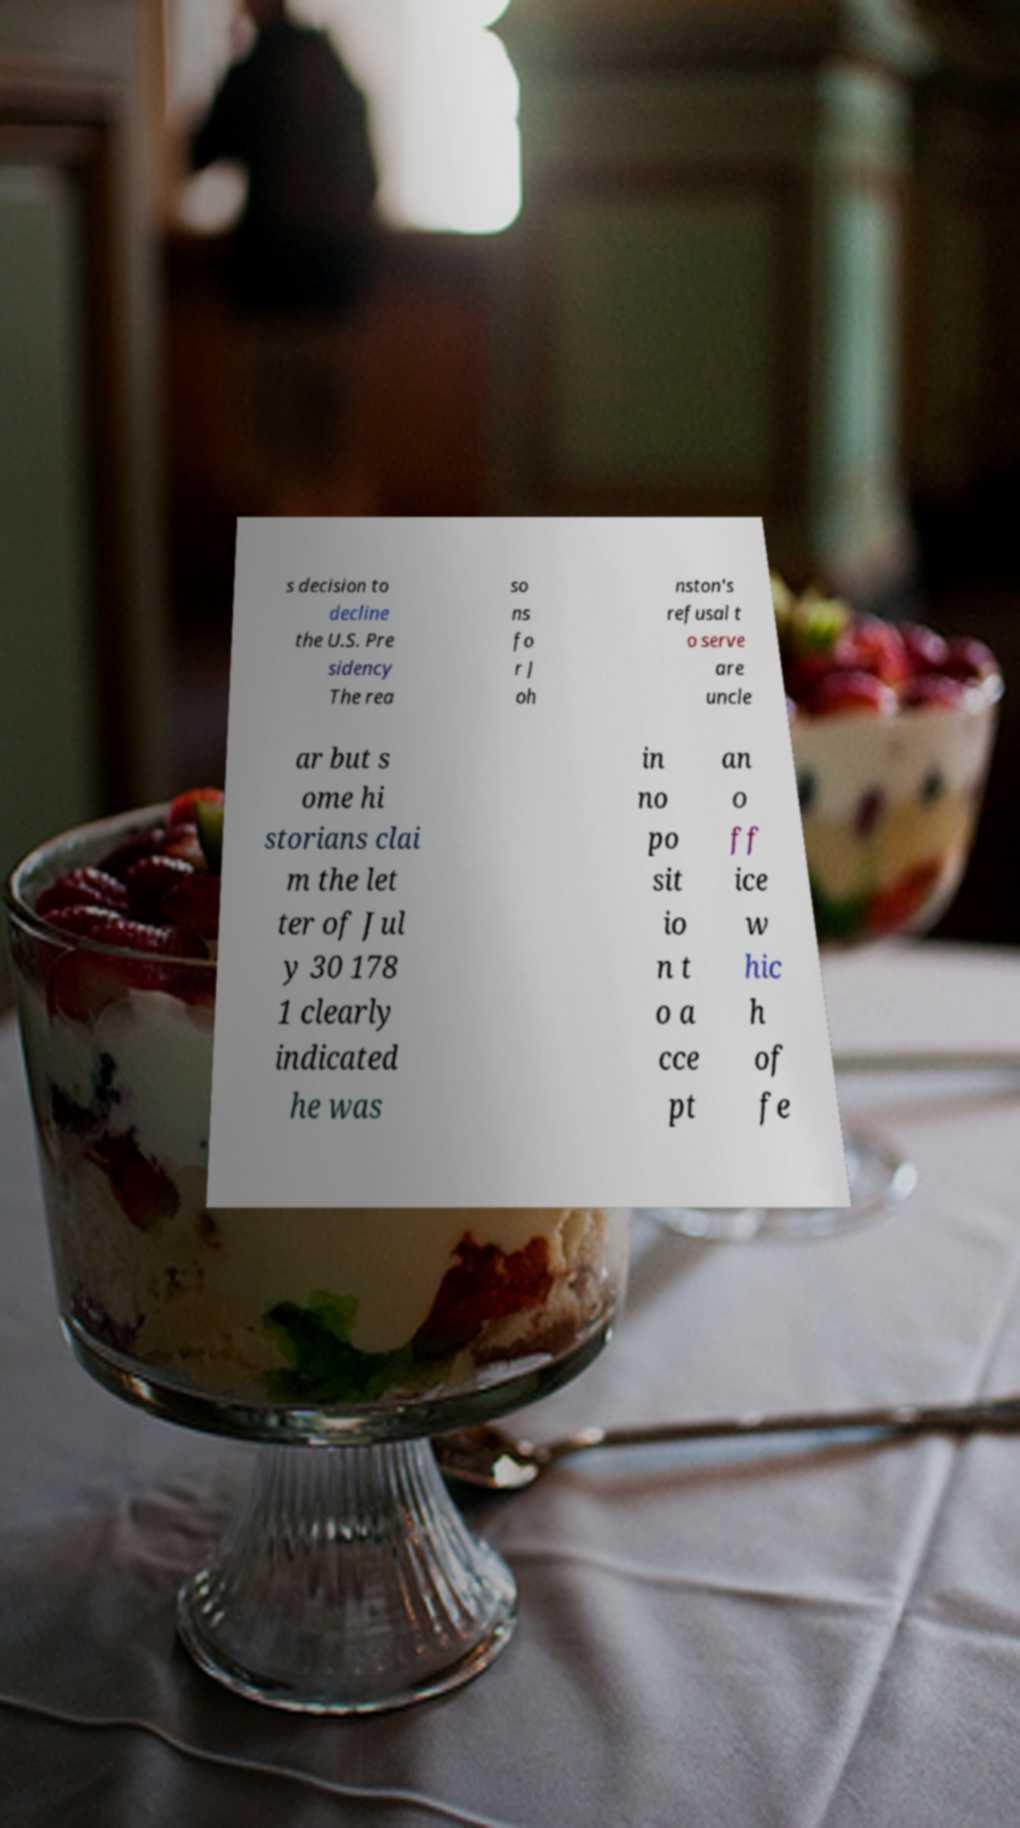Please identify and transcribe the text found in this image. s decision to decline the U.S. Pre sidency The rea so ns fo r J oh nston's refusal t o serve are uncle ar but s ome hi storians clai m the let ter of Jul y 30 178 1 clearly indicated he was in no po sit io n t o a cce pt an o ff ice w hic h of fe 